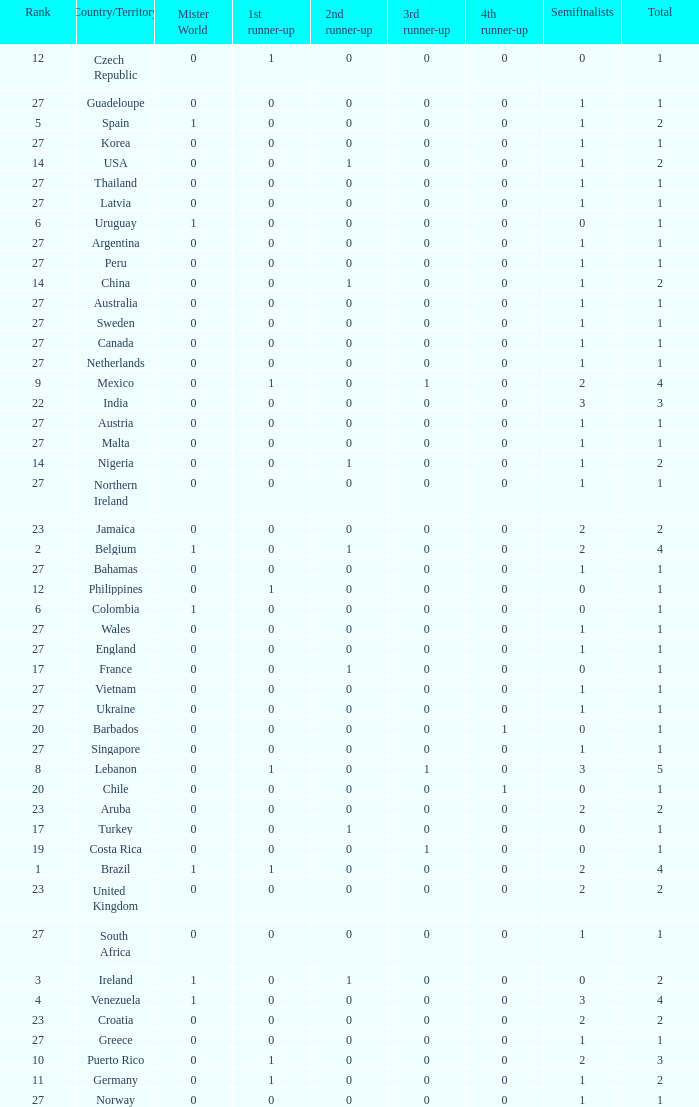What is the number of 1st runner up values for Jamaica? 1.0. 